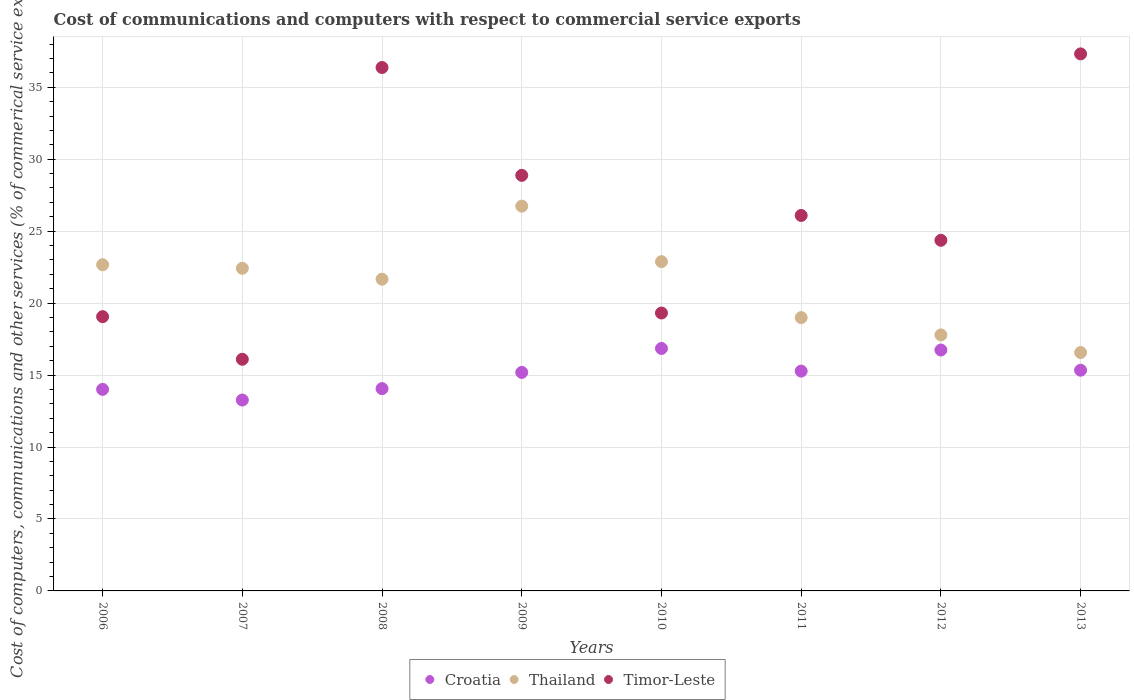How many different coloured dotlines are there?
Offer a very short reply. 3. What is the cost of communications and computers in Croatia in 2009?
Your answer should be compact. 15.18. Across all years, what is the maximum cost of communications and computers in Timor-Leste?
Give a very brief answer. 37.32. Across all years, what is the minimum cost of communications and computers in Timor-Leste?
Your response must be concise. 16.1. In which year was the cost of communications and computers in Croatia maximum?
Ensure brevity in your answer.  2010. What is the total cost of communications and computers in Croatia in the graph?
Offer a terse response. 120.71. What is the difference between the cost of communications and computers in Timor-Leste in 2007 and that in 2010?
Provide a succinct answer. -3.22. What is the difference between the cost of communications and computers in Thailand in 2013 and the cost of communications and computers in Croatia in 2012?
Your answer should be very brief. -0.17. What is the average cost of communications and computers in Thailand per year?
Provide a short and direct response. 21.21. In the year 2009, what is the difference between the cost of communications and computers in Croatia and cost of communications and computers in Timor-Leste?
Provide a succinct answer. -13.69. What is the ratio of the cost of communications and computers in Thailand in 2006 to that in 2012?
Give a very brief answer. 1.27. Is the cost of communications and computers in Timor-Leste in 2007 less than that in 2012?
Give a very brief answer. Yes. What is the difference between the highest and the second highest cost of communications and computers in Thailand?
Ensure brevity in your answer.  3.86. What is the difference between the highest and the lowest cost of communications and computers in Croatia?
Make the answer very short. 3.58. In how many years, is the cost of communications and computers in Thailand greater than the average cost of communications and computers in Thailand taken over all years?
Ensure brevity in your answer.  5. Is the sum of the cost of communications and computers in Croatia in 2011 and 2013 greater than the maximum cost of communications and computers in Thailand across all years?
Your answer should be compact. Yes. Does the cost of communications and computers in Thailand monotonically increase over the years?
Your answer should be very brief. No. Is the cost of communications and computers in Croatia strictly greater than the cost of communications and computers in Thailand over the years?
Your answer should be compact. No. How many dotlines are there?
Keep it short and to the point. 3. What is the difference between two consecutive major ticks on the Y-axis?
Offer a very short reply. 5. Does the graph contain grids?
Provide a short and direct response. Yes. What is the title of the graph?
Give a very brief answer. Cost of communications and computers with respect to commercial service exports. What is the label or title of the X-axis?
Your answer should be very brief. Years. What is the label or title of the Y-axis?
Your response must be concise. Cost of computers, communications and other services (% of commerical service exports). What is the Cost of computers, communications and other services (% of commerical service exports) of Croatia in 2006?
Make the answer very short. 14. What is the Cost of computers, communications and other services (% of commerical service exports) in Thailand in 2006?
Offer a terse response. 22.66. What is the Cost of computers, communications and other services (% of commerical service exports) in Timor-Leste in 2006?
Ensure brevity in your answer.  19.06. What is the Cost of computers, communications and other services (% of commerical service exports) in Croatia in 2007?
Make the answer very short. 13.26. What is the Cost of computers, communications and other services (% of commerical service exports) of Thailand in 2007?
Make the answer very short. 22.42. What is the Cost of computers, communications and other services (% of commerical service exports) of Timor-Leste in 2007?
Offer a very short reply. 16.1. What is the Cost of computers, communications and other services (% of commerical service exports) in Croatia in 2008?
Ensure brevity in your answer.  14.06. What is the Cost of computers, communications and other services (% of commerical service exports) in Thailand in 2008?
Make the answer very short. 21.66. What is the Cost of computers, communications and other services (% of commerical service exports) in Timor-Leste in 2008?
Provide a succinct answer. 36.37. What is the Cost of computers, communications and other services (% of commerical service exports) in Croatia in 2009?
Your answer should be compact. 15.18. What is the Cost of computers, communications and other services (% of commerical service exports) in Thailand in 2009?
Offer a very short reply. 26.74. What is the Cost of computers, communications and other services (% of commerical service exports) of Timor-Leste in 2009?
Your answer should be very brief. 28.88. What is the Cost of computers, communications and other services (% of commerical service exports) in Croatia in 2010?
Ensure brevity in your answer.  16.85. What is the Cost of computers, communications and other services (% of commerical service exports) in Thailand in 2010?
Make the answer very short. 22.88. What is the Cost of computers, communications and other services (% of commerical service exports) in Timor-Leste in 2010?
Offer a terse response. 19.31. What is the Cost of computers, communications and other services (% of commerical service exports) of Croatia in 2011?
Ensure brevity in your answer.  15.28. What is the Cost of computers, communications and other services (% of commerical service exports) in Thailand in 2011?
Make the answer very short. 18.99. What is the Cost of computers, communications and other services (% of commerical service exports) in Timor-Leste in 2011?
Your answer should be very brief. 26.09. What is the Cost of computers, communications and other services (% of commerical service exports) of Croatia in 2012?
Offer a terse response. 16.74. What is the Cost of computers, communications and other services (% of commerical service exports) in Thailand in 2012?
Provide a succinct answer. 17.79. What is the Cost of computers, communications and other services (% of commerical service exports) in Timor-Leste in 2012?
Your response must be concise. 24.36. What is the Cost of computers, communications and other services (% of commerical service exports) in Croatia in 2013?
Ensure brevity in your answer.  15.34. What is the Cost of computers, communications and other services (% of commerical service exports) of Thailand in 2013?
Make the answer very short. 16.56. What is the Cost of computers, communications and other services (% of commerical service exports) of Timor-Leste in 2013?
Your answer should be compact. 37.32. Across all years, what is the maximum Cost of computers, communications and other services (% of commerical service exports) of Croatia?
Keep it short and to the point. 16.85. Across all years, what is the maximum Cost of computers, communications and other services (% of commerical service exports) of Thailand?
Make the answer very short. 26.74. Across all years, what is the maximum Cost of computers, communications and other services (% of commerical service exports) of Timor-Leste?
Provide a succinct answer. 37.32. Across all years, what is the minimum Cost of computers, communications and other services (% of commerical service exports) of Croatia?
Offer a terse response. 13.26. Across all years, what is the minimum Cost of computers, communications and other services (% of commerical service exports) in Thailand?
Give a very brief answer. 16.56. Across all years, what is the minimum Cost of computers, communications and other services (% of commerical service exports) in Timor-Leste?
Provide a succinct answer. 16.1. What is the total Cost of computers, communications and other services (% of commerical service exports) of Croatia in the graph?
Keep it short and to the point. 120.71. What is the total Cost of computers, communications and other services (% of commerical service exports) in Thailand in the graph?
Your answer should be very brief. 169.71. What is the total Cost of computers, communications and other services (% of commerical service exports) of Timor-Leste in the graph?
Offer a very short reply. 207.48. What is the difference between the Cost of computers, communications and other services (% of commerical service exports) in Croatia in 2006 and that in 2007?
Keep it short and to the point. 0.74. What is the difference between the Cost of computers, communications and other services (% of commerical service exports) of Thailand in 2006 and that in 2007?
Provide a short and direct response. 0.25. What is the difference between the Cost of computers, communications and other services (% of commerical service exports) in Timor-Leste in 2006 and that in 2007?
Ensure brevity in your answer.  2.96. What is the difference between the Cost of computers, communications and other services (% of commerical service exports) in Croatia in 2006 and that in 2008?
Your answer should be compact. -0.05. What is the difference between the Cost of computers, communications and other services (% of commerical service exports) of Thailand in 2006 and that in 2008?
Give a very brief answer. 1. What is the difference between the Cost of computers, communications and other services (% of commerical service exports) in Timor-Leste in 2006 and that in 2008?
Make the answer very short. -17.31. What is the difference between the Cost of computers, communications and other services (% of commerical service exports) of Croatia in 2006 and that in 2009?
Provide a succinct answer. -1.18. What is the difference between the Cost of computers, communications and other services (% of commerical service exports) in Thailand in 2006 and that in 2009?
Give a very brief answer. -4.07. What is the difference between the Cost of computers, communications and other services (% of commerical service exports) of Timor-Leste in 2006 and that in 2009?
Provide a short and direct response. -9.82. What is the difference between the Cost of computers, communications and other services (% of commerical service exports) in Croatia in 2006 and that in 2010?
Provide a short and direct response. -2.84. What is the difference between the Cost of computers, communications and other services (% of commerical service exports) of Thailand in 2006 and that in 2010?
Offer a very short reply. -0.22. What is the difference between the Cost of computers, communications and other services (% of commerical service exports) of Timor-Leste in 2006 and that in 2010?
Your response must be concise. -0.25. What is the difference between the Cost of computers, communications and other services (% of commerical service exports) in Croatia in 2006 and that in 2011?
Give a very brief answer. -1.27. What is the difference between the Cost of computers, communications and other services (% of commerical service exports) of Thailand in 2006 and that in 2011?
Provide a short and direct response. 3.67. What is the difference between the Cost of computers, communications and other services (% of commerical service exports) of Timor-Leste in 2006 and that in 2011?
Your answer should be very brief. -7.03. What is the difference between the Cost of computers, communications and other services (% of commerical service exports) in Croatia in 2006 and that in 2012?
Offer a terse response. -2.73. What is the difference between the Cost of computers, communications and other services (% of commerical service exports) in Thailand in 2006 and that in 2012?
Offer a terse response. 4.87. What is the difference between the Cost of computers, communications and other services (% of commerical service exports) of Timor-Leste in 2006 and that in 2012?
Offer a very short reply. -5.31. What is the difference between the Cost of computers, communications and other services (% of commerical service exports) in Croatia in 2006 and that in 2013?
Offer a terse response. -1.33. What is the difference between the Cost of computers, communications and other services (% of commerical service exports) in Thailand in 2006 and that in 2013?
Provide a succinct answer. 6.1. What is the difference between the Cost of computers, communications and other services (% of commerical service exports) in Timor-Leste in 2006 and that in 2013?
Your answer should be compact. -18.26. What is the difference between the Cost of computers, communications and other services (% of commerical service exports) of Croatia in 2007 and that in 2008?
Provide a succinct answer. -0.79. What is the difference between the Cost of computers, communications and other services (% of commerical service exports) in Thailand in 2007 and that in 2008?
Provide a succinct answer. 0.76. What is the difference between the Cost of computers, communications and other services (% of commerical service exports) of Timor-Leste in 2007 and that in 2008?
Offer a very short reply. -20.27. What is the difference between the Cost of computers, communications and other services (% of commerical service exports) of Croatia in 2007 and that in 2009?
Offer a very short reply. -1.92. What is the difference between the Cost of computers, communications and other services (% of commerical service exports) of Thailand in 2007 and that in 2009?
Give a very brief answer. -4.32. What is the difference between the Cost of computers, communications and other services (% of commerical service exports) in Timor-Leste in 2007 and that in 2009?
Offer a terse response. -12.78. What is the difference between the Cost of computers, communications and other services (% of commerical service exports) of Croatia in 2007 and that in 2010?
Offer a terse response. -3.58. What is the difference between the Cost of computers, communications and other services (% of commerical service exports) of Thailand in 2007 and that in 2010?
Give a very brief answer. -0.46. What is the difference between the Cost of computers, communications and other services (% of commerical service exports) in Timor-Leste in 2007 and that in 2010?
Provide a short and direct response. -3.22. What is the difference between the Cost of computers, communications and other services (% of commerical service exports) of Croatia in 2007 and that in 2011?
Ensure brevity in your answer.  -2.01. What is the difference between the Cost of computers, communications and other services (% of commerical service exports) in Thailand in 2007 and that in 2011?
Your answer should be very brief. 3.43. What is the difference between the Cost of computers, communications and other services (% of commerical service exports) of Timor-Leste in 2007 and that in 2011?
Offer a terse response. -9.99. What is the difference between the Cost of computers, communications and other services (% of commerical service exports) of Croatia in 2007 and that in 2012?
Offer a very short reply. -3.47. What is the difference between the Cost of computers, communications and other services (% of commerical service exports) of Thailand in 2007 and that in 2012?
Provide a succinct answer. 4.63. What is the difference between the Cost of computers, communications and other services (% of commerical service exports) in Timor-Leste in 2007 and that in 2012?
Offer a terse response. -8.27. What is the difference between the Cost of computers, communications and other services (% of commerical service exports) in Croatia in 2007 and that in 2013?
Make the answer very short. -2.07. What is the difference between the Cost of computers, communications and other services (% of commerical service exports) of Thailand in 2007 and that in 2013?
Make the answer very short. 5.85. What is the difference between the Cost of computers, communications and other services (% of commerical service exports) in Timor-Leste in 2007 and that in 2013?
Your answer should be very brief. -21.22. What is the difference between the Cost of computers, communications and other services (% of commerical service exports) of Croatia in 2008 and that in 2009?
Offer a very short reply. -1.13. What is the difference between the Cost of computers, communications and other services (% of commerical service exports) of Thailand in 2008 and that in 2009?
Offer a very short reply. -5.08. What is the difference between the Cost of computers, communications and other services (% of commerical service exports) in Timor-Leste in 2008 and that in 2009?
Offer a terse response. 7.49. What is the difference between the Cost of computers, communications and other services (% of commerical service exports) of Croatia in 2008 and that in 2010?
Offer a terse response. -2.79. What is the difference between the Cost of computers, communications and other services (% of commerical service exports) of Thailand in 2008 and that in 2010?
Ensure brevity in your answer.  -1.22. What is the difference between the Cost of computers, communications and other services (% of commerical service exports) in Timor-Leste in 2008 and that in 2010?
Give a very brief answer. 17.06. What is the difference between the Cost of computers, communications and other services (% of commerical service exports) in Croatia in 2008 and that in 2011?
Ensure brevity in your answer.  -1.22. What is the difference between the Cost of computers, communications and other services (% of commerical service exports) in Thailand in 2008 and that in 2011?
Your answer should be compact. 2.67. What is the difference between the Cost of computers, communications and other services (% of commerical service exports) in Timor-Leste in 2008 and that in 2011?
Ensure brevity in your answer.  10.28. What is the difference between the Cost of computers, communications and other services (% of commerical service exports) in Croatia in 2008 and that in 2012?
Your response must be concise. -2.68. What is the difference between the Cost of computers, communications and other services (% of commerical service exports) in Thailand in 2008 and that in 2012?
Provide a short and direct response. 3.87. What is the difference between the Cost of computers, communications and other services (% of commerical service exports) of Timor-Leste in 2008 and that in 2012?
Your response must be concise. 12.01. What is the difference between the Cost of computers, communications and other services (% of commerical service exports) of Croatia in 2008 and that in 2013?
Give a very brief answer. -1.28. What is the difference between the Cost of computers, communications and other services (% of commerical service exports) of Thailand in 2008 and that in 2013?
Your response must be concise. 5.1. What is the difference between the Cost of computers, communications and other services (% of commerical service exports) in Timor-Leste in 2008 and that in 2013?
Give a very brief answer. -0.95. What is the difference between the Cost of computers, communications and other services (% of commerical service exports) of Croatia in 2009 and that in 2010?
Give a very brief answer. -1.66. What is the difference between the Cost of computers, communications and other services (% of commerical service exports) of Thailand in 2009 and that in 2010?
Your answer should be compact. 3.86. What is the difference between the Cost of computers, communications and other services (% of commerical service exports) of Timor-Leste in 2009 and that in 2010?
Offer a terse response. 9.57. What is the difference between the Cost of computers, communications and other services (% of commerical service exports) in Croatia in 2009 and that in 2011?
Your response must be concise. -0.09. What is the difference between the Cost of computers, communications and other services (% of commerical service exports) of Thailand in 2009 and that in 2011?
Offer a very short reply. 7.75. What is the difference between the Cost of computers, communications and other services (% of commerical service exports) in Timor-Leste in 2009 and that in 2011?
Your response must be concise. 2.79. What is the difference between the Cost of computers, communications and other services (% of commerical service exports) of Croatia in 2009 and that in 2012?
Give a very brief answer. -1.55. What is the difference between the Cost of computers, communications and other services (% of commerical service exports) of Thailand in 2009 and that in 2012?
Offer a terse response. 8.95. What is the difference between the Cost of computers, communications and other services (% of commerical service exports) of Timor-Leste in 2009 and that in 2012?
Make the answer very short. 4.51. What is the difference between the Cost of computers, communications and other services (% of commerical service exports) in Croatia in 2009 and that in 2013?
Your response must be concise. -0.15. What is the difference between the Cost of computers, communications and other services (% of commerical service exports) in Thailand in 2009 and that in 2013?
Keep it short and to the point. 10.17. What is the difference between the Cost of computers, communications and other services (% of commerical service exports) of Timor-Leste in 2009 and that in 2013?
Your response must be concise. -8.44. What is the difference between the Cost of computers, communications and other services (% of commerical service exports) of Croatia in 2010 and that in 2011?
Offer a very short reply. 1.57. What is the difference between the Cost of computers, communications and other services (% of commerical service exports) of Thailand in 2010 and that in 2011?
Your answer should be very brief. 3.89. What is the difference between the Cost of computers, communications and other services (% of commerical service exports) in Timor-Leste in 2010 and that in 2011?
Ensure brevity in your answer.  -6.78. What is the difference between the Cost of computers, communications and other services (% of commerical service exports) in Croatia in 2010 and that in 2012?
Ensure brevity in your answer.  0.11. What is the difference between the Cost of computers, communications and other services (% of commerical service exports) of Thailand in 2010 and that in 2012?
Your answer should be very brief. 5.09. What is the difference between the Cost of computers, communications and other services (% of commerical service exports) in Timor-Leste in 2010 and that in 2012?
Your response must be concise. -5.05. What is the difference between the Cost of computers, communications and other services (% of commerical service exports) in Croatia in 2010 and that in 2013?
Offer a terse response. 1.51. What is the difference between the Cost of computers, communications and other services (% of commerical service exports) in Thailand in 2010 and that in 2013?
Provide a short and direct response. 6.32. What is the difference between the Cost of computers, communications and other services (% of commerical service exports) in Timor-Leste in 2010 and that in 2013?
Your answer should be compact. -18.01. What is the difference between the Cost of computers, communications and other services (% of commerical service exports) of Croatia in 2011 and that in 2012?
Your answer should be very brief. -1.46. What is the difference between the Cost of computers, communications and other services (% of commerical service exports) in Thailand in 2011 and that in 2012?
Provide a short and direct response. 1.2. What is the difference between the Cost of computers, communications and other services (% of commerical service exports) in Timor-Leste in 2011 and that in 2012?
Provide a succinct answer. 1.73. What is the difference between the Cost of computers, communications and other services (% of commerical service exports) of Croatia in 2011 and that in 2013?
Ensure brevity in your answer.  -0.06. What is the difference between the Cost of computers, communications and other services (% of commerical service exports) of Thailand in 2011 and that in 2013?
Provide a succinct answer. 2.43. What is the difference between the Cost of computers, communications and other services (% of commerical service exports) of Timor-Leste in 2011 and that in 2013?
Your answer should be compact. -11.23. What is the difference between the Cost of computers, communications and other services (% of commerical service exports) in Croatia in 2012 and that in 2013?
Ensure brevity in your answer.  1.4. What is the difference between the Cost of computers, communications and other services (% of commerical service exports) in Thailand in 2012 and that in 2013?
Provide a succinct answer. 1.23. What is the difference between the Cost of computers, communications and other services (% of commerical service exports) of Timor-Leste in 2012 and that in 2013?
Keep it short and to the point. -12.95. What is the difference between the Cost of computers, communications and other services (% of commerical service exports) in Croatia in 2006 and the Cost of computers, communications and other services (% of commerical service exports) in Thailand in 2007?
Provide a short and direct response. -8.41. What is the difference between the Cost of computers, communications and other services (% of commerical service exports) in Croatia in 2006 and the Cost of computers, communications and other services (% of commerical service exports) in Timor-Leste in 2007?
Make the answer very short. -2.09. What is the difference between the Cost of computers, communications and other services (% of commerical service exports) in Thailand in 2006 and the Cost of computers, communications and other services (% of commerical service exports) in Timor-Leste in 2007?
Provide a short and direct response. 6.57. What is the difference between the Cost of computers, communications and other services (% of commerical service exports) of Croatia in 2006 and the Cost of computers, communications and other services (% of commerical service exports) of Thailand in 2008?
Provide a succinct answer. -7.66. What is the difference between the Cost of computers, communications and other services (% of commerical service exports) in Croatia in 2006 and the Cost of computers, communications and other services (% of commerical service exports) in Timor-Leste in 2008?
Ensure brevity in your answer.  -22.36. What is the difference between the Cost of computers, communications and other services (% of commerical service exports) in Thailand in 2006 and the Cost of computers, communications and other services (% of commerical service exports) in Timor-Leste in 2008?
Offer a terse response. -13.71. What is the difference between the Cost of computers, communications and other services (% of commerical service exports) of Croatia in 2006 and the Cost of computers, communications and other services (% of commerical service exports) of Thailand in 2009?
Provide a short and direct response. -12.73. What is the difference between the Cost of computers, communications and other services (% of commerical service exports) in Croatia in 2006 and the Cost of computers, communications and other services (% of commerical service exports) in Timor-Leste in 2009?
Your response must be concise. -14.87. What is the difference between the Cost of computers, communications and other services (% of commerical service exports) of Thailand in 2006 and the Cost of computers, communications and other services (% of commerical service exports) of Timor-Leste in 2009?
Your response must be concise. -6.21. What is the difference between the Cost of computers, communications and other services (% of commerical service exports) of Croatia in 2006 and the Cost of computers, communications and other services (% of commerical service exports) of Thailand in 2010?
Offer a very short reply. -8.88. What is the difference between the Cost of computers, communications and other services (% of commerical service exports) of Croatia in 2006 and the Cost of computers, communications and other services (% of commerical service exports) of Timor-Leste in 2010?
Your answer should be very brief. -5.31. What is the difference between the Cost of computers, communications and other services (% of commerical service exports) in Thailand in 2006 and the Cost of computers, communications and other services (% of commerical service exports) in Timor-Leste in 2010?
Offer a terse response. 3.35. What is the difference between the Cost of computers, communications and other services (% of commerical service exports) in Croatia in 2006 and the Cost of computers, communications and other services (% of commerical service exports) in Thailand in 2011?
Make the answer very short. -4.99. What is the difference between the Cost of computers, communications and other services (% of commerical service exports) of Croatia in 2006 and the Cost of computers, communications and other services (% of commerical service exports) of Timor-Leste in 2011?
Your answer should be very brief. -12.09. What is the difference between the Cost of computers, communications and other services (% of commerical service exports) of Thailand in 2006 and the Cost of computers, communications and other services (% of commerical service exports) of Timor-Leste in 2011?
Your answer should be very brief. -3.43. What is the difference between the Cost of computers, communications and other services (% of commerical service exports) of Croatia in 2006 and the Cost of computers, communications and other services (% of commerical service exports) of Thailand in 2012?
Keep it short and to the point. -3.79. What is the difference between the Cost of computers, communications and other services (% of commerical service exports) in Croatia in 2006 and the Cost of computers, communications and other services (% of commerical service exports) in Timor-Leste in 2012?
Ensure brevity in your answer.  -10.36. What is the difference between the Cost of computers, communications and other services (% of commerical service exports) of Thailand in 2006 and the Cost of computers, communications and other services (% of commerical service exports) of Timor-Leste in 2012?
Offer a very short reply. -1.7. What is the difference between the Cost of computers, communications and other services (% of commerical service exports) of Croatia in 2006 and the Cost of computers, communications and other services (% of commerical service exports) of Thailand in 2013?
Your answer should be very brief. -2.56. What is the difference between the Cost of computers, communications and other services (% of commerical service exports) in Croatia in 2006 and the Cost of computers, communications and other services (% of commerical service exports) in Timor-Leste in 2013?
Offer a very short reply. -23.31. What is the difference between the Cost of computers, communications and other services (% of commerical service exports) in Thailand in 2006 and the Cost of computers, communications and other services (% of commerical service exports) in Timor-Leste in 2013?
Give a very brief answer. -14.65. What is the difference between the Cost of computers, communications and other services (% of commerical service exports) of Croatia in 2007 and the Cost of computers, communications and other services (% of commerical service exports) of Thailand in 2008?
Your answer should be compact. -8.4. What is the difference between the Cost of computers, communications and other services (% of commerical service exports) of Croatia in 2007 and the Cost of computers, communications and other services (% of commerical service exports) of Timor-Leste in 2008?
Your response must be concise. -23.11. What is the difference between the Cost of computers, communications and other services (% of commerical service exports) of Thailand in 2007 and the Cost of computers, communications and other services (% of commerical service exports) of Timor-Leste in 2008?
Your answer should be compact. -13.95. What is the difference between the Cost of computers, communications and other services (% of commerical service exports) of Croatia in 2007 and the Cost of computers, communications and other services (% of commerical service exports) of Thailand in 2009?
Make the answer very short. -13.47. What is the difference between the Cost of computers, communications and other services (% of commerical service exports) in Croatia in 2007 and the Cost of computers, communications and other services (% of commerical service exports) in Timor-Leste in 2009?
Offer a terse response. -15.61. What is the difference between the Cost of computers, communications and other services (% of commerical service exports) in Thailand in 2007 and the Cost of computers, communications and other services (% of commerical service exports) in Timor-Leste in 2009?
Your answer should be compact. -6.46. What is the difference between the Cost of computers, communications and other services (% of commerical service exports) in Croatia in 2007 and the Cost of computers, communications and other services (% of commerical service exports) in Thailand in 2010?
Provide a short and direct response. -9.62. What is the difference between the Cost of computers, communications and other services (% of commerical service exports) of Croatia in 2007 and the Cost of computers, communications and other services (% of commerical service exports) of Timor-Leste in 2010?
Offer a very short reply. -6.05. What is the difference between the Cost of computers, communications and other services (% of commerical service exports) in Thailand in 2007 and the Cost of computers, communications and other services (% of commerical service exports) in Timor-Leste in 2010?
Offer a very short reply. 3.11. What is the difference between the Cost of computers, communications and other services (% of commerical service exports) in Croatia in 2007 and the Cost of computers, communications and other services (% of commerical service exports) in Thailand in 2011?
Provide a short and direct response. -5.73. What is the difference between the Cost of computers, communications and other services (% of commerical service exports) of Croatia in 2007 and the Cost of computers, communications and other services (% of commerical service exports) of Timor-Leste in 2011?
Offer a terse response. -12.83. What is the difference between the Cost of computers, communications and other services (% of commerical service exports) of Thailand in 2007 and the Cost of computers, communications and other services (% of commerical service exports) of Timor-Leste in 2011?
Keep it short and to the point. -3.67. What is the difference between the Cost of computers, communications and other services (% of commerical service exports) of Croatia in 2007 and the Cost of computers, communications and other services (% of commerical service exports) of Thailand in 2012?
Your answer should be very brief. -4.53. What is the difference between the Cost of computers, communications and other services (% of commerical service exports) of Croatia in 2007 and the Cost of computers, communications and other services (% of commerical service exports) of Timor-Leste in 2012?
Provide a short and direct response. -11.1. What is the difference between the Cost of computers, communications and other services (% of commerical service exports) in Thailand in 2007 and the Cost of computers, communications and other services (% of commerical service exports) in Timor-Leste in 2012?
Offer a terse response. -1.95. What is the difference between the Cost of computers, communications and other services (% of commerical service exports) in Croatia in 2007 and the Cost of computers, communications and other services (% of commerical service exports) in Thailand in 2013?
Give a very brief answer. -3.3. What is the difference between the Cost of computers, communications and other services (% of commerical service exports) in Croatia in 2007 and the Cost of computers, communications and other services (% of commerical service exports) in Timor-Leste in 2013?
Give a very brief answer. -24.05. What is the difference between the Cost of computers, communications and other services (% of commerical service exports) in Thailand in 2007 and the Cost of computers, communications and other services (% of commerical service exports) in Timor-Leste in 2013?
Make the answer very short. -14.9. What is the difference between the Cost of computers, communications and other services (% of commerical service exports) of Croatia in 2008 and the Cost of computers, communications and other services (% of commerical service exports) of Thailand in 2009?
Provide a short and direct response. -12.68. What is the difference between the Cost of computers, communications and other services (% of commerical service exports) of Croatia in 2008 and the Cost of computers, communications and other services (% of commerical service exports) of Timor-Leste in 2009?
Make the answer very short. -14.82. What is the difference between the Cost of computers, communications and other services (% of commerical service exports) of Thailand in 2008 and the Cost of computers, communications and other services (% of commerical service exports) of Timor-Leste in 2009?
Your answer should be very brief. -7.22. What is the difference between the Cost of computers, communications and other services (% of commerical service exports) in Croatia in 2008 and the Cost of computers, communications and other services (% of commerical service exports) in Thailand in 2010?
Your answer should be compact. -8.82. What is the difference between the Cost of computers, communications and other services (% of commerical service exports) of Croatia in 2008 and the Cost of computers, communications and other services (% of commerical service exports) of Timor-Leste in 2010?
Give a very brief answer. -5.25. What is the difference between the Cost of computers, communications and other services (% of commerical service exports) in Thailand in 2008 and the Cost of computers, communications and other services (% of commerical service exports) in Timor-Leste in 2010?
Your response must be concise. 2.35. What is the difference between the Cost of computers, communications and other services (% of commerical service exports) of Croatia in 2008 and the Cost of computers, communications and other services (% of commerical service exports) of Thailand in 2011?
Your answer should be very brief. -4.93. What is the difference between the Cost of computers, communications and other services (% of commerical service exports) in Croatia in 2008 and the Cost of computers, communications and other services (% of commerical service exports) in Timor-Leste in 2011?
Provide a short and direct response. -12.03. What is the difference between the Cost of computers, communications and other services (% of commerical service exports) in Thailand in 2008 and the Cost of computers, communications and other services (% of commerical service exports) in Timor-Leste in 2011?
Your answer should be compact. -4.43. What is the difference between the Cost of computers, communications and other services (% of commerical service exports) in Croatia in 2008 and the Cost of computers, communications and other services (% of commerical service exports) in Thailand in 2012?
Give a very brief answer. -3.73. What is the difference between the Cost of computers, communications and other services (% of commerical service exports) of Croatia in 2008 and the Cost of computers, communications and other services (% of commerical service exports) of Timor-Leste in 2012?
Offer a terse response. -10.31. What is the difference between the Cost of computers, communications and other services (% of commerical service exports) of Thailand in 2008 and the Cost of computers, communications and other services (% of commerical service exports) of Timor-Leste in 2012?
Your response must be concise. -2.7. What is the difference between the Cost of computers, communications and other services (% of commerical service exports) of Croatia in 2008 and the Cost of computers, communications and other services (% of commerical service exports) of Thailand in 2013?
Offer a very short reply. -2.51. What is the difference between the Cost of computers, communications and other services (% of commerical service exports) in Croatia in 2008 and the Cost of computers, communications and other services (% of commerical service exports) in Timor-Leste in 2013?
Your answer should be very brief. -23.26. What is the difference between the Cost of computers, communications and other services (% of commerical service exports) of Thailand in 2008 and the Cost of computers, communications and other services (% of commerical service exports) of Timor-Leste in 2013?
Provide a succinct answer. -15.66. What is the difference between the Cost of computers, communications and other services (% of commerical service exports) of Croatia in 2009 and the Cost of computers, communications and other services (% of commerical service exports) of Thailand in 2010?
Your response must be concise. -7.7. What is the difference between the Cost of computers, communications and other services (% of commerical service exports) in Croatia in 2009 and the Cost of computers, communications and other services (% of commerical service exports) in Timor-Leste in 2010?
Provide a succinct answer. -4.13. What is the difference between the Cost of computers, communications and other services (% of commerical service exports) in Thailand in 2009 and the Cost of computers, communications and other services (% of commerical service exports) in Timor-Leste in 2010?
Give a very brief answer. 7.43. What is the difference between the Cost of computers, communications and other services (% of commerical service exports) of Croatia in 2009 and the Cost of computers, communications and other services (% of commerical service exports) of Thailand in 2011?
Keep it short and to the point. -3.81. What is the difference between the Cost of computers, communications and other services (% of commerical service exports) of Croatia in 2009 and the Cost of computers, communications and other services (% of commerical service exports) of Timor-Leste in 2011?
Keep it short and to the point. -10.91. What is the difference between the Cost of computers, communications and other services (% of commerical service exports) in Thailand in 2009 and the Cost of computers, communications and other services (% of commerical service exports) in Timor-Leste in 2011?
Keep it short and to the point. 0.65. What is the difference between the Cost of computers, communications and other services (% of commerical service exports) of Croatia in 2009 and the Cost of computers, communications and other services (% of commerical service exports) of Thailand in 2012?
Give a very brief answer. -2.61. What is the difference between the Cost of computers, communications and other services (% of commerical service exports) of Croatia in 2009 and the Cost of computers, communications and other services (% of commerical service exports) of Timor-Leste in 2012?
Keep it short and to the point. -9.18. What is the difference between the Cost of computers, communications and other services (% of commerical service exports) of Thailand in 2009 and the Cost of computers, communications and other services (% of commerical service exports) of Timor-Leste in 2012?
Make the answer very short. 2.37. What is the difference between the Cost of computers, communications and other services (% of commerical service exports) of Croatia in 2009 and the Cost of computers, communications and other services (% of commerical service exports) of Thailand in 2013?
Make the answer very short. -1.38. What is the difference between the Cost of computers, communications and other services (% of commerical service exports) of Croatia in 2009 and the Cost of computers, communications and other services (% of commerical service exports) of Timor-Leste in 2013?
Offer a terse response. -22.13. What is the difference between the Cost of computers, communications and other services (% of commerical service exports) of Thailand in 2009 and the Cost of computers, communications and other services (% of commerical service exports) of Timor-Leste in 2013?
Provide a succinct answer. -10.58. What is the difference between the Cost of computers, communications and other services (% of commerical service exports) of Croatia in 2010 and the Cost of computers, communications and other services (% of commerical service exports) of Thailand in 2011?
Your response must be concise. -2.14. What is the difference between the Cost of computers, communications and other services (% of commerical service exports) in Croatia in 2010 and the Cost of computers, communications and other services (% of commerical service exports) in Timor-Leste in 2011?
Offer a terse response. -9.24. What is the difference between the Cost of computers, communications and other services (% of commerical service exports) of Thailand in 2010 and the Cost of computers, communications and other services (% of commerical service exports) of Timor-Leste in 2011?
Give a very brief answer. -3.21. What is the difference between the Cost of computers, communications and other services (% of commerical service exports) in Croatia in 2010 and the Cost of computers, communications and other services (% of commerical service exports) in Thailand in 2012?
Offer a very short reply. -0.94. What is the difference between the Cost of computers, communications and other services (% of commerical service exports) of Croatia in 2010 and the Cost of computers, communications and other services (% of commerical service exports) of Timor-Leste in 2012?
Offer a very short reply. -7.52. What is the difference between the Cost of computers, communications and other services (% of commerical service exports) in Thailand in 2010 and the Cost of computers, communications and other services (% of commerical service exports) in Timor-Leste in 2012?
Your response must be concise. -1.48. What is the difference between the Cost of computers, communications and other services (% of commerical service exports) of Croatia in 2010 and the Cost of computers, communications and other services (% of commerical service exports) of Thailand in 2013?
Keep it short and to the point. 0.28. What is the difference between the Cost of computers, communications and other services (% of commerical service exports) of Croatia in 2010 and the Cost of computers, communications and other services (% of commerical service exports) of Timor-Leste in 2013?
Offer a very short reply. -20.47. What is the difference between the Cost of computers, communications and other services (% of commerical service exports) in Thailand in 2010 and the Cost of computers, communications and other services (% of commerical service exports) in Timor-Leste in 2013?
Make the answer very short. -14.44. What is the difference between the Cost of computers, communications and other services (% of commerical service exports) of Croatia in 2011 and the Cost of computers, communications and other services (% of commerical service exports) of Thailand in 2012?
Make the answer very short. -2.51. What is the difference between the Cost of computers, communications and other services (% of commerical service exports) in Croatia in 2011 and the Cost of computers, communications and other services (% of commerical service exports) in Timor-Leste in 2012?
Offer a terse response. -9.09. What is the difference between the Cost of computers, communications and other services (% of commerical service exports) in Thailand in 2011 and the Cost of computers, communications and other services (% of commerical service exports) in Timor-Leste in 2012?
Make the answer very short. -5.37. What is the difference between the Cost of computers, communications and other services (% of commerical service exports) in Croatia in 2011 and the Cost of computers, communications and other services (% of commerical service exports) in Thailand in 2013?
Keep it short and to the point. -1.29. What is the difference between the Cost of computers, communications and other services (% of commerical service exports) of Croatia in 2011 and the Cost of computers, communications and other services (% of commerical service exports) of Timor-Leste in 2013?
Your answer should be very brief. -22.04. What is the difference between the Cost of computers, communications and other services (% of commerical service exports) of Thailand in 2011 and the Cost of computers, communications and other services (% of commerical service exports) of Timor-Leste in 2013?
Provide a short and direct response. -18.32. What is the difference between the Cost of computers, communications and other services (% of commerical service exports) in Croatia in 2012 and the Cost of computers, communications and other services (% of commerical service exports) in Thailand in 2013?
Your answer should be compact. 0.17. What is the difference between the Cost of computers, communications and other services (% of commerical service exports) in Croatia in 2012 and the Cost of computers, communications and other services (% of commerical service exports) in Timor-Leste in 2013?
Give a very brief answer. -20.58. What is the difference between the Cost of computers, communications and other services (% of commerical service exports) in Thailand in 2012 and the Cost of computers, communications and other services (% of commerical service exports) in Timor-Leste in 2013?
Provide a short and direct response. -19.53. What is the average Cost of computers, communications and other services (% of commerical service exports) of Croatia per year?
Give a very brief answer. 15.09. What is the average Cost of computers, communications and other services (% of commerical service exports) in Thailand per year?
Offer a terse response. 21.21. What is the average Cost of computers, communications and other services (% of commerical service exports) of Timor-Leste per year?
Provide a short and direct response. 25.94. In the year 2006, what is the difference between the Cost of computers, communications and other services (% of commerical service exports) in Croatia and Cost of computers, communications and other services (% of commerical service exports) in Thailand?
Your response must be concise. -8.66. In the year 2006, what is the difference between the Cost of computers, communications and other services (% of commerical service exports) of Croatia and Cost of computers, communications and other services (% of commerical service exports) of Timor-Leste?
Ensure brevity in your answer.  -5.05. In the year 2006, what is the difference between the Cost of computers, communications and other services (% of commerical service exports) of Thailand and Cost of computers, communications and other services (% of commerical service exports) of Timor-Leste?
Ensure brevity in your answer.  3.61. In the year 2007, what is the difference between the Cost of computers, communications and other services (% of commerical service exports) of Croatia and Cost of computers, communications and other services (% of commerical service exports) of Thailand?
Your answer should be very brief. -9.15. In the year 2007, what is the difference between the Cost of computers, communications and other services (% of commerical service exports) of Croatia and Cost of computers, communications and other services (% of commerical service exports) of Timor-Leste?
Make the answer very short. -2.83. In the year 2007, what is the difference between the Cost of computers, communications and other services (% of commerical service exports) of Thailand and Cost of computers, communications and other services (% of commerical service exports) of Timor-Leste?
Your answer should be compact. 6.32. In the year 2008, what is the difference between the Cost of computers, communications and other services (% of commerical service exports) of Croatia and Cost of computers, communications and other services (% of commerical service exports) of Thailand?
Provide a succinct answer. -7.6. In the year 2008, what is the difference between the Cost of computers, communications and other services (% of commerical service exports) in Croatia and Cost of computers, communications and other services (% of commerical service exports) in Timor-Leste?
Your response must be concise. -22.31. In the year 2008, what is the difference between the Cost of computers, communications and other services (% of commerical service exports) of Thailand and Cost of computers, communications and other services (% of commerical service exports) of Timor-Leste?
Provide a short and direct response. -14.71. In the year 2009, what is the difference between the Cost of computers, communications and other services (% of commerical service exports) of Croatia and Cost of computers, communications and other services (% of commerical service exports) of Thailand?
Your answer should be very brief. -11.55. In the year 2009, what is the difference between the Cost of computers, communications and other services (% of commerical service exports) of Croatia and Cost of computers, communications and other services (% of commerical service exports) of Timor-Leste?
Your response must be concise. -13.69. In the year 2009, what is the difference between the Cost of computers, communications and other services (% of commerical service exports) in Thailand and Cost of computers, communications and other services (% of commerical service exports) in Timor-Leste?
Your answer should be very brief. -2.14. In the year 2010, what is the difference between the Cost of computers, communications and other services (% of commerical service exports) in Croatia and Cost of computers, communications and other services (% of commerical service exports) in Thailand?
Ensure brevity in your answer.  -6.03. In the year 2010, what is the difference between the Cost of computers, communications and other services (% of commerical service exports) in Croatia and Cost of computers, communications and other services (% of commerical service exports) in Timor-Leste?
Give a very brief answer. -2.46. In the year 2010, what is the difference between the Cost of computers, communications and other services (% of commerical service exports) in Thailand and Cost of computers, communications and other services (% of commerical service exports) in Timor-Leste?
Provide a succinct answer. 3.57. In the year 2011, what is the difference between the Cost of computers, communications and other services (% of commerical service exports) in Croatia and Cost of computers, communications and other services (% of commerical service exports) in Thailand?
Your answer should be compact. -3.72. In the year 2011, what is the difference between the Cost of computers, communications and other services (% of commerical service exports) in Croatia and Cost of computers, communications and other services (% of commerical service exports) in Timor-Leste?
Give a very brief answer. -10.81. In the year 2011, what is the difference between the Cost of computers, communications and other services (% of commerical service exports) of Thailand and Cost of computers, communications and other services (% of commerical service exports) of Timor-Leste?
Give a very brief answer. -7.1. In the year 2012, what is the difference between the Cost of computers, communications and other services (% of commerical service exports) in Croatia and Cost of computers, communications and other services (% of commerical service exports) in Thailand?
Provide a succinct answer. -1.05. In the year 2012, what is the difference between the Cost of computers, communications and other services (% of commerical service exports) in Croatia and Cost of computers, communications and other services (% of commerical service exports) in Timor-Leste?
Your answer should be very brief. -7.62. In the year 2012, what is the difference between the Cost of computers, communications and other services (% of commerical service exports) of Thailand and Cost of computers, communications and other services (% of commerical service exports) of Timor-Leste?
Keep it short and to the point. -6.57. In the year 2013, what is the difference between the Cost of computers, communications and other services (% of commerical service exports) of Croatia and Cost of computers, communications and other services (% of commerical service exports) of Thailand?
Your answer should be compact. -1.23. In the year 2013, what is the difference between the Cost of computers, communications and other services (% of commerical service exports) of Croatia and Cost of computers, communications and other services (% of commerical service exports) of Timor-Leste?
Your answer should be very brief. -21.98. In the year 2013, what is the difference between the Cost of computers, communications and other services (% of commerical service exports) in Thailand and Cost of computers, communications and other services (% of commerical service exports) in Timor-Leste?
Make the answer very short. -20.75. What is the ratio of the Cost of computers, communications and other services (% of commerical service exports) of Croatia in 2006 to that in 2007?
Offer a very short reply. 1.06. What is the ratio of the Cost of computers, communications and other services (% of commerical service exports) of Thailand in 2006 to that in 2007?
Keep it short and to the point. 1.01. What is the ratio of the Cost of computers, communications and other services (% of commerical service exports) of Timor-Leste in 2006 to that in 2007?
Your answer should be compact. 1.18. What is the ratio of the Cost of computers, communications and other services (% of commerical service exports) of Croatia in 2006 to that in 2008?
Give a very brief answer. 1. What is the ratio of the Cost of computers, communications and other services (% of commerical service exports) in Thailand in 2006 to that in 2008?
Your answer should be compact. 1.05. What is the ratio of the Cost of computers, communications and other services (% of commerical service exports) in Timor-Leste in 2006 to that in 2008?
Your answer should be very brief. 0.52. What is the ratio of the Cost of computers, communications and other services (% of commerical service exports) in Croatia in 2006 to that in 2009?
Your answer should be compact. 0.92. What is the ratio of the Cost of computers, communications and other services (% of commerical service exports) of Thailand in 2006 to that in 2009?
Provide a short and direct response. 0.85. What is the ratio of the Cost of computers, communications and other services (% of commerical service exports) of Timor-Leste in 2006 to that in 2009?
Give a very brief answer. 0.66. What is the ratio of the Cost of computers, communications and other services (% of commerical service exports) in Croatia in 2006 to that in 2010?
Make the answer very short. 0.83. What is the ratio of the Cost of computers, communications and other services (% of commerical service exports) in Croatia in 2006 to that in 2011?
Provide a succinct answer. 0.92. What is the ratio of the Cost of computers, communications and other services (% of commerical service exports) in Thailand in 2006 to that in 2011?
Offer a terse response. 1.19. What is the ratio of the Cost of computers, communications and other services (% of commerical service exports) of Timor-Leste in 2006 to that in 2011?
Offer a terse response. 0.73. What is the ratio of the Cost of computers, communications and other services (% of commerical service exports) in Croatia in 2006 to that in 2012?
Provide a short and direct response. 0.84. What is the ratio of the Cost of computers, communications and other services (% of commerical service exports) of Thailand in 2006 to that in 2012?
Ensure brevity in your answer.  1.27. What is the ratio of the Cost of computers, communications and other services (% of commerical service exports) in Timor-Leste in 2006 to that in 2012?
Offer a terse response. 0.78. What is the ratio of the Cost of computers, communications and other services (% of commerical service exports) in Croatia in 2006 to that in 2013?
Keep it short and to the point. 0.91. What is the ratio of the Cost of computers, communications and other services (% of commerical service exports) of Thailand in 2006 to that in 2013?
Make the answer very short. 1.37. What is the ratio of the Cost of computers, communications and other services (% of commerical service exports) in Timor-Leste in 2006 to that in 2013?
Give a very brief answer. 0.51. What is the ratio of the Cost of computers, communications and other services (% of commerical service exports) in Croatia in 2007 to that in 2008?
Offer a very short reply. 0.94. What is the ratio of the Cost of computers, communications and other services (% of commerical service exports) in Thailand in 2007 to that in 2008?
Ensure brevity in your answer.  1.03. What is the ratio of the Cost of computers, communications and other services (% of commerical service exports) of Timor-Leste in 2007 to that in 2008?
Offer a very short reply. 0.44. What is the ratio of the Cost of computers, communications and other services (% of commerical service exports) in Croatia in 2007 to that in 2009?
Your response must be concise. 0.87. What is the ratio of the Cost of computers, communications and other services (% of commerical service exports) of Thailand in 2007 to that in 2009?
Provide a short and direct response. 0.84. What is the ratio of the Cost of computers, communications and other services (% of commerical service exports) in Timor-Leste in 2007 to that in 2009?
Ensure brevity in your answer.  0.56. What is the ratio of the Cost of computers, communications and other services (% of commerical service exports) in Croatia in 2007 to that in 2010?
Make the answer very short. 0.79. What is the ratio of the Cost of computers, communications and other services (% of commerical service exports) of Thailand in 2007 to that in 2010?
Give a very brief answer. 0.98. What is the ratio of the Cost of computers, communications and other services (% of commerical service exports) in Timor-Leste in 2007 to that in 2010?
Your answer should be very brief. 0.83. What is the ratio of the Cost of computers, communications and other services (% of commerical service exports) of Croatia in 2007 to that in 2011?
Your answer should be compact. 0.87. What is the ratio of the Cost of computers, communications and other services (% of commerical service exports) of Thailand in 2007 to that in 2011?
Your answer should be very brief. 1.18. What is the ratio of the Cost of computers, communications and other services (% of commerical service exports) in Timor-Leste in 2007 to that in 2011?
Offer a terse response. 0.62. What is the ratio of the Cost of computers, communications and other services (% of commerical service exports) in Croatia in 2007 to that in 2012?
Your response must be concise. 0.79. What is the ratio of the Cost of computers, communications and other services (% of commerical service exports) of Thailand in 2007 to that in 2012?
Make the answer very short. 1.26. What is the ratio of the Cost of computers, communications and other services (% of commerical service exports) in Timor-Leste in 2007 to that in 2012?
Keep it short and to the point. 0.66. What is the ratio of the Cost of computers, communications and other services (% of commerical service exports) in Croatia in 2007 to that in 2013?
Keep it short and to the point. 0.86. What is the ratio of the Cost of computers, communications and other services (% of commerical service exports) in Thailand in 2007 to that in 2013?
Provide a short and direct response. 1.35. What is the ratio of the Cost of computers, communications and other services (% of commerical service exports) of Timor-Leste in 2007 to that in 2013?
Provide a succinct answer. 0.43. What is the ratio of the Cost of computers, communications and other services (% of commerical service exports) of Croatia in 2008 to that in 2009?
Your answer should be compact. 0.93. What is the ratio of the Cost of computers, communications and other services (% of commerical service exports) in Thailand in 2008 to that in 2009?
Your answer should be compact. 0.81. What is the ratio of the Cost of computers, communications and other services (% of commerical service exports) in Timor-Leste in 2008 to that in 2009?
Offer a very short reply. 1.26. What is the ratio of the Cost of computers, communications and other services (% of commerical service exports) in Croatia in 2008 to that in 2010?
Your response must be concise. 0.83. What is the ratio of the Cost of computers, communications and other services (% of commerical service exports) of Thailand in 2008 to that in 2010?
Offer a very short reply. 0.95. What is the ratio of the Cost of computers, communications and other services (% of commerical service exports) of Timor-Leste in 2008 to that in 2010?
Ensure brevity in your answer.  1.88. What is the ratio of the Cost of computers, communications and other services (% of commerical service exports) of Croatia in 2008 to that in 2011?
Make the answer very short. 0.92. What is the ratio of the Cost of computers, communications and other services (% of commerical service exports) in Thailand in 2008 to that in 2011?
Your answer should be very brief. 1.14. What is the ratio of the Cost of computers, communications and other services (% of commerical service exports) in Timor-Leste in 2008 to that in 2011?
Ensure brevity in your answer.  1.39. What is the ratio of the Cost of computers, communications and other services (% of commerical service exports) in Croatia in 2008 to that in 2012?
Your answer should be very brief. 0.84. What is the ratio of the Cost of computers, communications and other services (% of commerical service exports) in Thailand in 2008 to that in 2012?
Your answer should be very brief. 1.22. What is the ratio of the Cost of computers, communications and other services (% of commerical service exports) of Timor-Leste in 2008 to that in 2012?
Your response must be concise. 1.49. What is the ratio of the Cost of computers, communications and other services (% of commerical service exports) of Croatia in 2008 to that in 2013?
Your answer should be very brief. 0.92. What is the ratio of the Cost of computers, communications and other services (% of commerical service exports) in Thailand in 2008 to that in 2013?
Give a very brief answer. 1.31. What is the ratio of the Cost of computers, communications and other services (% of commerical service exports) of Timor-Leste in 2008 to that in 2013?
Your answer should be very brief. 0.97. What is the ratio of the Cost of computers, communications and other services (% of commerical service exports) of Croatia in 2009 to that in 2010?
Provide a succinct answer. 0.9. What is the ratio of the Cost of computers, communications and other services (% of commerical service exports) in Thailand in 2009 to that in 2010?
Offer a very short reply. 1.17. What is the ratio of the Cost of computers, communications and other services (% of commerical service exports) in Timor-Leste in 2009 to that in 2010?
Provide a short and direct response. 1.5. What is the ratio of the Cost of computers, communications and other services (% of commerical service exports) in Croatia in 2009 to that in 2011?
Your answer should be compact. 0.99. What is the ratio of the Cost of computers, communications and other services (% of commerical service exports) of Thailand in 2009 to that in 2011?
Keep it short and to the point. 1.41. What is the ratio of the Cost of computers, communications and other services (% of commerical service exports) of Timor-Leste in 2009 to that in 2011?
Offer a very short reply. 1.11. What is the ratio of the Cost of computers, communications and other services (% of commerical service exports) in Croatia in 2009 to that in 2012?
Your answer should be compact. 0.91. What is the ratio of the Cost of computers, communications and other services (% of commerical service exports) of Thailand in 2009 to that in 2012?
Give a very brief answer. 1.5. What is the ratio of the Cost of computers, communications and other services (% of commerical service exports) of Timor-Leste in 2009 to that in 2012?
Give a very brief answer. 1.19. What is the ratio of the Cost of computers, communications and other services (% of commerical service exports) in Thailand in 2009 to that in 2013?
Your answer should be very brief. 1.61. What is the ratio of the Cost of computers, communications and other services (% of commerical service exports) of Timor-Leste in 2009 to that in 2013?
Offer a very short reply. 0.77. What is the ratio of the Cost of computers, communications and other services (% of commerical service exports) in Croatia in 2010 to that in 2011?
Provide a succinct answer. 1.1. What is the ratio of the Cost of computers, communications and other services (% of commerical service exports) of Thailand in 2010 to that in 2011?
Ensure brevity in your answer.  1.2. What is the ratio of the Cost of computers, communications and other services (% of commerical service exports) of Timor-Leste in 2010 to that in 2011?
Keep it short and to the point. 0.74. What is the ratio of the Cost of computers, communications and other services (% of commerical service exports) in Thailand in 2010 to that in 2012?
Give a very brief answer. 1.29. What is the ratio of the Cost of computers, communications and other services (% of commerical service exports) of Timor-Leste in 2010 to that in 2012?
Make the answer very short. 0.79. What is the ratio of the Cost of computers, communications and other services (% of commerical service exports) in Croatia in 2010 to that in 2013?
Give a very brief answer. 1.1. What is the ratio of the Cost of computers, communications and other services (% of commerical service exports) of Thailand in 2010 to that in 2013?
Give a very brief answer. 1.38. What is the ratio of the Cost of computers, communications and other services (% of commerical service exports) of Timor-Leste in 2010 to that in 2013?
Ensure brevity in your answer.  0.52. What is the ratio of the Cost of computers, communications and other services (% of commerical service exports) of Croatia in 2011 to that in 2012?
Provide a short and direct response. 0.91. What is the ratio of the Cost of computers, communications and other services (% of commerical service exports) of Thailand in 2011 to that in 2012?
Offer a very short reply. 1.07. What is the ratio of the Cost of computers, communications and other services (% of commerical service exports) of Timor-Leste in 2011 to that in 2012?
Your answer should be compact. 1.07. What is the ratio of the Cost of computers, communications and other services (% of commerical service exports) in Thailand in 2011 to that in 2013?
Ensure brevity in your answer.  1.15. What is the ratio of the Cost of computers, communications and other services (% of commerical service exports) in Timor-Leste in 2011 to that in 2013?
Keep it short and to the point. 0.7. What is the ratio of the Cost of computers, communications and other services (% of commerical service exports) in Croatia in 2012 to that in 2013?
Offer a very short reply. 1.09. What is the ratio of the Cost of computers, communications and other services (% of commerical service exports) in Thailand in 2012 to that in 2013?
Your answer should be compact. 1.07. What is the ratio of the Cost of computers, communications and other services (% of commerical service exports) in Timor-Leste in 2012 to that in 2013?
Ensure brevity in your answer.  0.65. What is the difference between the highest and the second highest Cost of computers, communications and other services (% of commerical service exports) in Croatia?
Give a very brief answer. 0.11. What is the difference between the highest and the second highest Cost of computers, communications and other services (% of commerical service exports) in Thailand?
Ensure brevity in your answer.  3.86. What is the difference between the highest and the second highest Cost of computers, communications and other services (% of commerical service exports) in Timor-Leste?
Your response must be concise. 0.95. What is the difference between the highest and the lowest Cost of computers, communications and other services (% of commerical service exports) of Croatia?
Keep it short and to the point. 3.58. What is the difference between the highest and the lowest Cost of computers, communications and other services (% of commerical service exports) in Thailand?
Your response must be concise. 10.17. What is the difference between the highest and the lowest Cost of computers, communications and other services (% of commerical service exports) of Timor-Leste?
Ensure brevity in your answer.  21.22. 